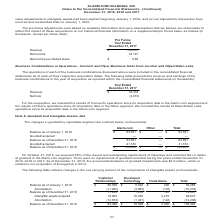According to Alarmcom Holdings's financial document, What was the goodwill acquired in 2019? According to the financial document, 41,372 (in thousands). The relevant text states: "cember 31, 2018 63,591 — 63,591 Goodwill acquired 41,372 — 41,372 Balance as of December 31, 2019 $ 104,963 $ — $ 104,963..." Also, What was the balance as of December 31, 2019? According to the financial document, 104,963 (in thousands). The relevant text states: "41,372 — 41,372 Balance as of December 31, 2019 $ 104,963 $ — $ 104,963..." Also, How much goodwill did the company record in the Alarm.com segment on October 21, 2019? According to the financial document, $41.4 million (in millions). The relevant text states: "outstanding capital stock of OpenEye and recorded $41.4 million of goodwill in the Alarm.com segment. There were no impairments of goodwill recorded during the year..." Also, can you calculate: What was the total balance as of January 1, 2018 as a percentage of the total balance on December 31, 2019? Based on the calculation: 63,591/104,963, the result is 60.58 (percentage). This is based on the information: "m.com Other Total Balance as of January 1, 2018 $ 63,591 $ — $ 63,591 Goodwill acquired — — — Balance as of December 31, 2018 63,591 — 63,591 Goodwill acqui 41,372 — 41,372 Balance as of December 31, ..." The key data points involved are: 104,963, 63,591. Also, can you calculate: What was the difference in goodwill acquired in 2019 and balance as of December 31, 2018? Based on the calculation: 63,591-41,372, the result is 22219 (in thousands). This is based on the information: "m.com Other Total Balance as of January 1, 2018 $ 63,591 $ — $ 63,591 Goodwill acquired — — — Balance as of December 31, 2018 63,591 — 63,591 Goodwill acqui cember 31, 2018 63,591 — 63,591 Goodwill ac..." The key data points involved are: 41,372, 63,591. Also, can you calculate: What was the percentage change in the balance between December 31, 2018 and 2019? To answer this question, I need to perform calculations using the financial data. The calculation is: (104,963-63,591)/63,591, which equals 65.06 (percentage). This is based on the information: "m.com Other Total Balance as of January 1, 2018 $ 63,591 $ — $ 63,591 Goodwill acquired — — — Balance as of December 31, 2018 63,591 — 63,591 Goodwill acqui 41,372 — 41,372 Balance as of December 31, ..." The key data points involved are: 104,963, 63,591. 